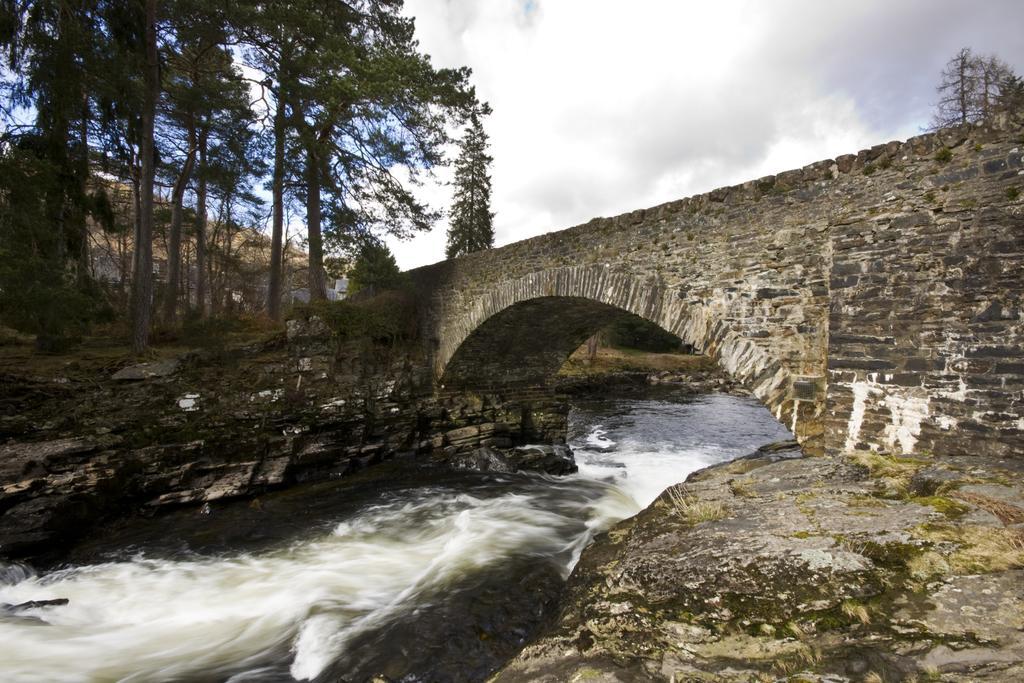Could you give a brief overview of what you see in this image? In this picture we can observe water flowing under this bridge. There are some trees. In the background there is a sky with some clouds. 